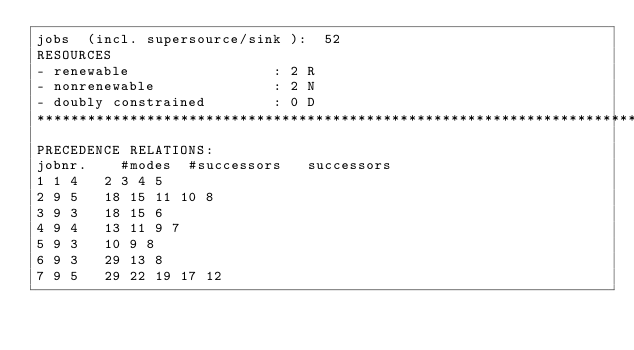Convert code to text. <code><loc_0><loc_0><loc_500><loc_500><_ObjectiveC_>jobs  (incl. supersource/sink ):	52
RESOURCES
- renewable                 : 2 R
- nonrenewable              : 2 N
- doubly constrained        : 0 D
************************************************************************
PRECEDENCE RELATIONS:
jobnr.    #modes  #successors   successors
1	1	4		2 3 4 5 
2	9	5		18 15 11 10 8 
3	9	3		18 15 6 
4	9	4		13 11 9 7 
5	9	3		10 9 8 
6	9	3		29 13 8 
7	9	5		29 22 19 17 12 </code> 